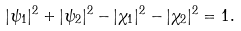<formula> <loc_0><loc_0><loc_500><loc_500>| \psi _ { 1 } | ^ { 2 } + | \psi _ { 2 } | ^ { 2 } - | \chi _ { 1 } | ^ { 2 } - | \chi _ { 2 } | ^ { 2 } = 1 .</formula> 